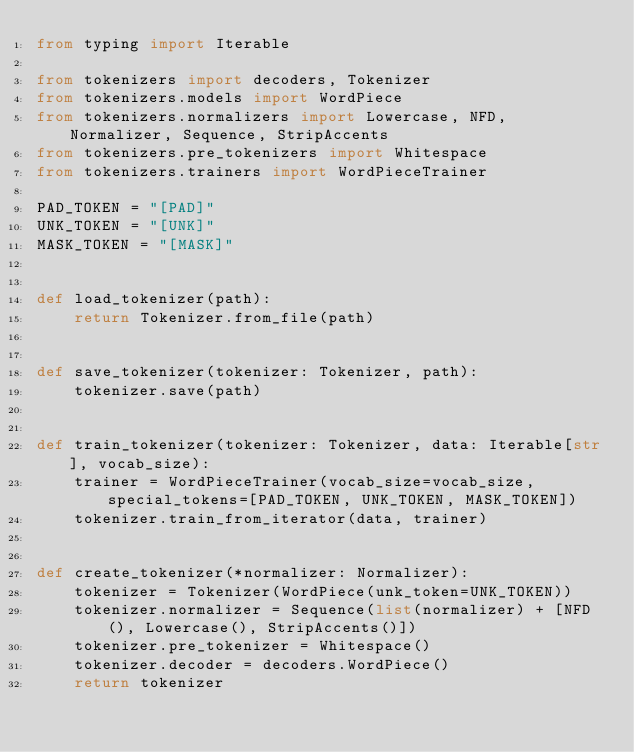<code> <loc_0><loc_0><loc_500><loc_500><_Python_>from typing import Iterable

from tokenizers import decoders, Tokenizer
from tokenizers.models import WordPiece
from tokenizers.normalizers import Lowercase, NFD, Normalizer, Sequence, StripAccents
from tokenizers.pre_tokenizers import Whitespace
from tokenizers.trainers import WordPieceTrainer

PAD_TOKEN = "[PAD]"
UNK_TOKEN = "[UNK]"
MASK_TOKEN = "[MASK]"


def load_tokenizer(path):
    return Tokenizer.from_file(path)


def save_tokenizer(tokenizer: Tokenizer, path):
    tokenizer.save(path)


def train_tokenizer(tokenizer: Tokenizer, data: Iterable[str], vocab_size):
    trainer = WordPieceTrainer(vocab_size=vocab_size, special_tokens=[PAD_TOKEN, UNK_TOKEN, MASK_TOKEN])
    tokenizer.train_from_iterator(data, trainer)


def create_tokenizer(*normalizer: Normalizer):
    tokenizer = Tokenizer(WordPiece(unk_token=UNK_TOKEN))
    tokenizer.normalizer = Sequence(list(normalizer) + [NFD(), Lowercase(), StripAccents()])
    tokenizer.pre_tokenizer = Whitespace()
    tokenizer.decoder = decoders.WordPiece()
    return tokenizer
</code> 